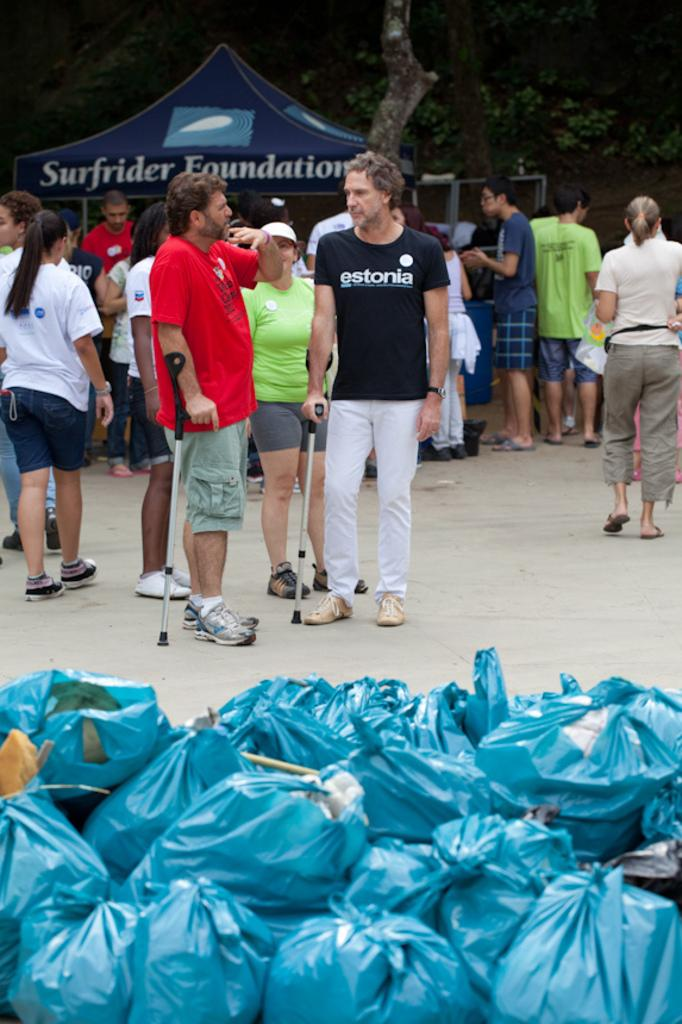Who or what can be seen in the image? There are people in the image. What is on the floor near the people? There are cover bags on the floor. What can be seen in the distance in the image? There is a tent in the background of the image, and there are also trees. What type of cup is being used for the operation in the image? There is no operation or cup present in the image. 